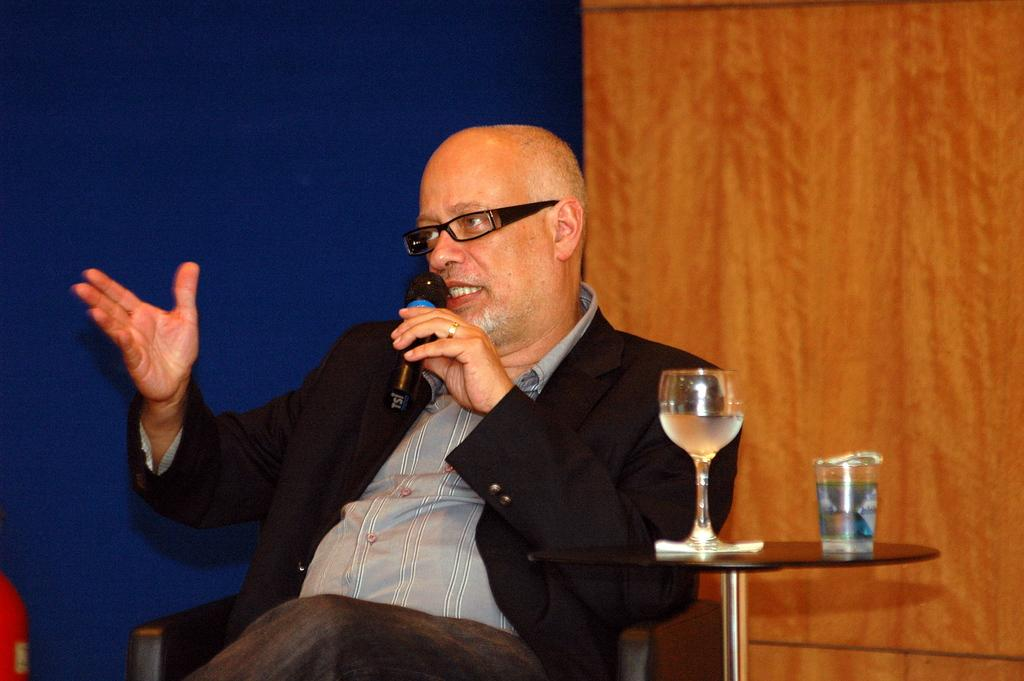Who is the main subject in the image? There is a man in the image. What is the man doing in the image? The man is sitting on a chair and holding a microphone. What else can be seen in the image besides the man? There is a table in the image, with glasses on it. There is also a wall behind the man. What is the tendency of the border in the image? There is no border present in the image, so it is not possible to determine any tendency. 